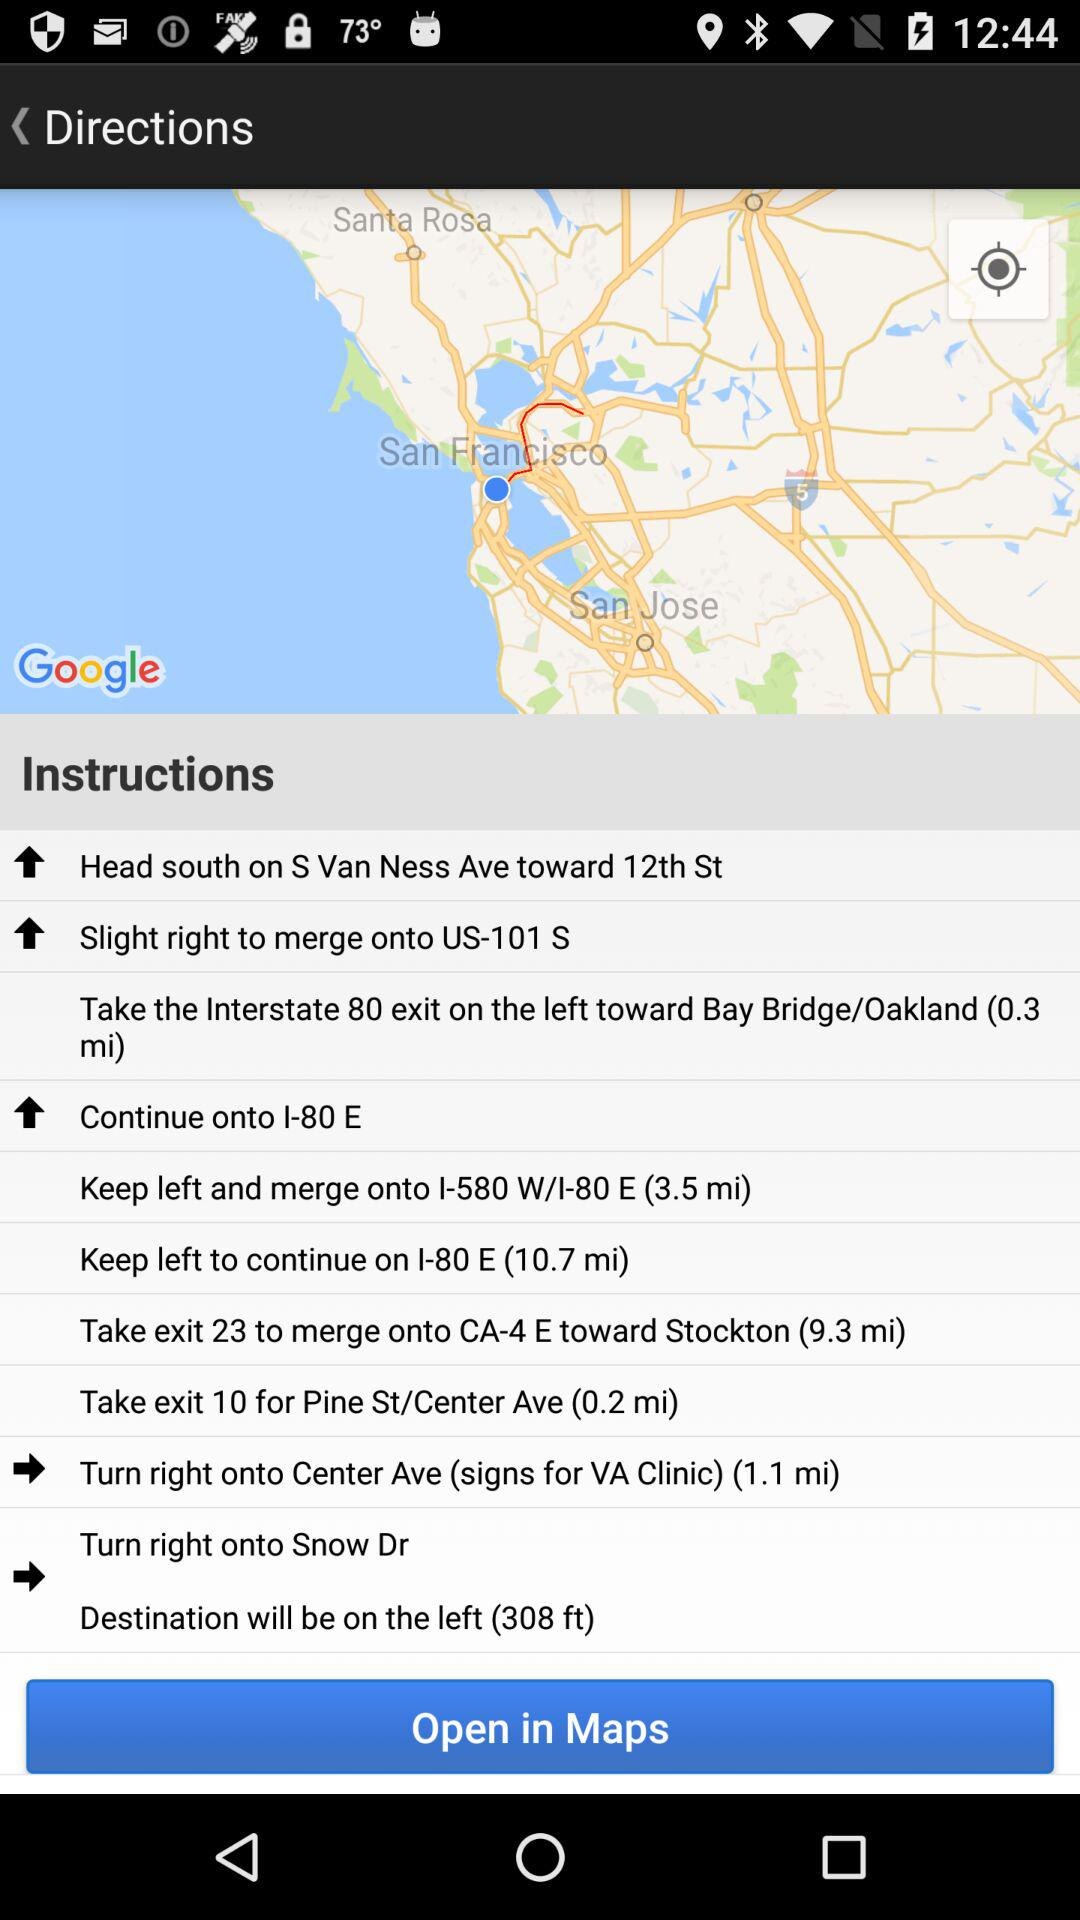How many steps are there in the directions?
Answer the question using a single word or phrase. 10 